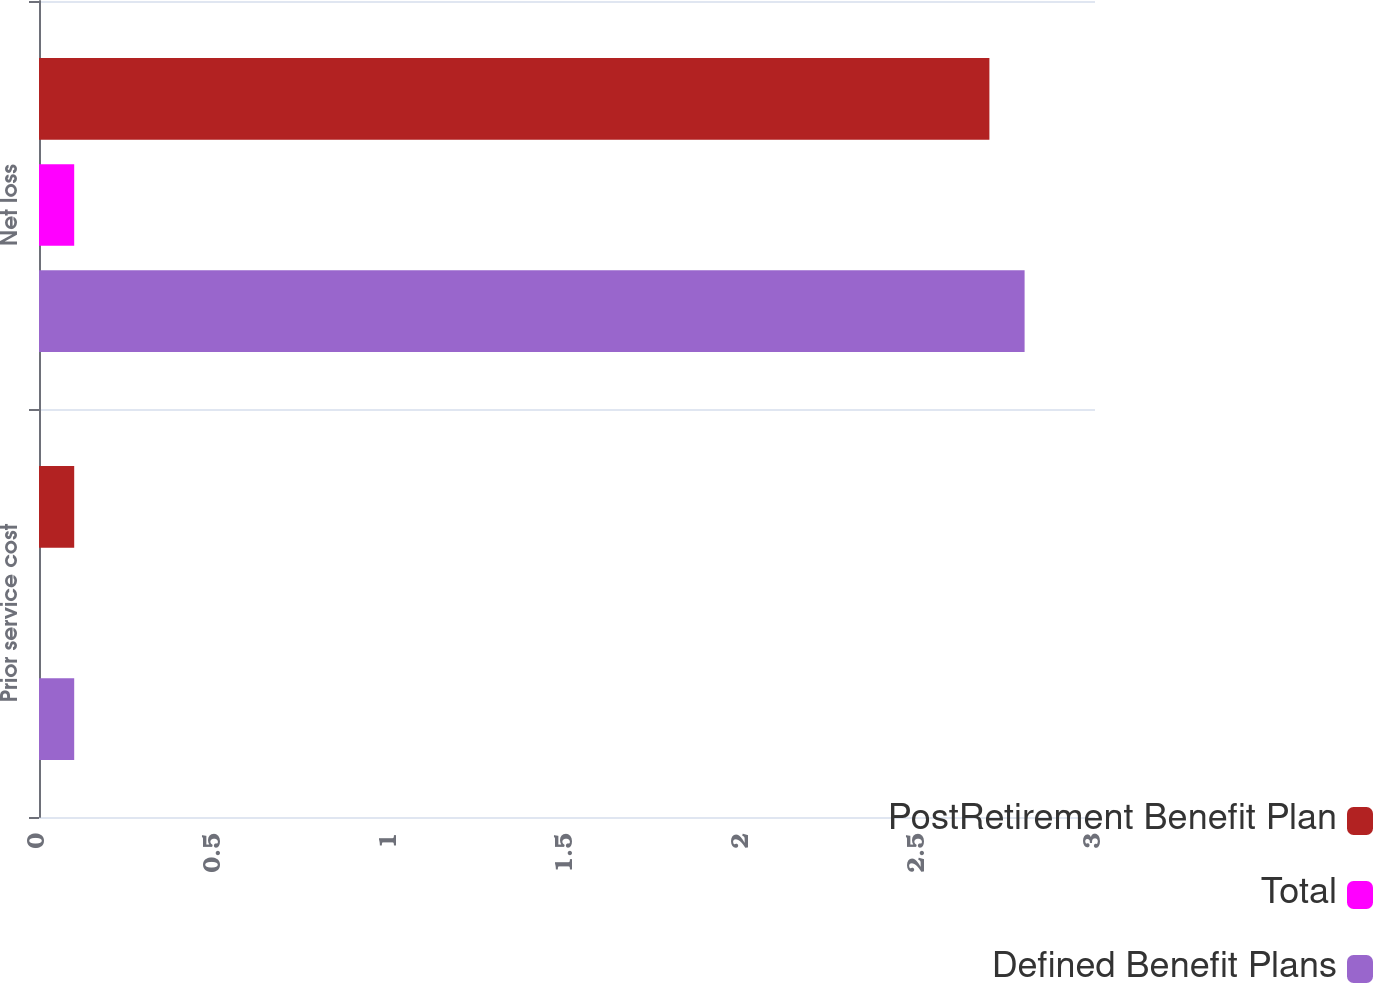Convert chart. <chart><loc_0><loc_0><loc_500><loc_500><stacked_bar_chart><ecel><fcel>Prior service cost<fcel>Net loss<nl><fcel>PostRetirement Benefit Plan<fcel>0.1<fcel>2.7<nl><fcel>Total<fcel>0<fcel>0.1<nl><fcel>Defined Benefit Plans<fcel>0.1<fcel>2.8<nl></chart> 